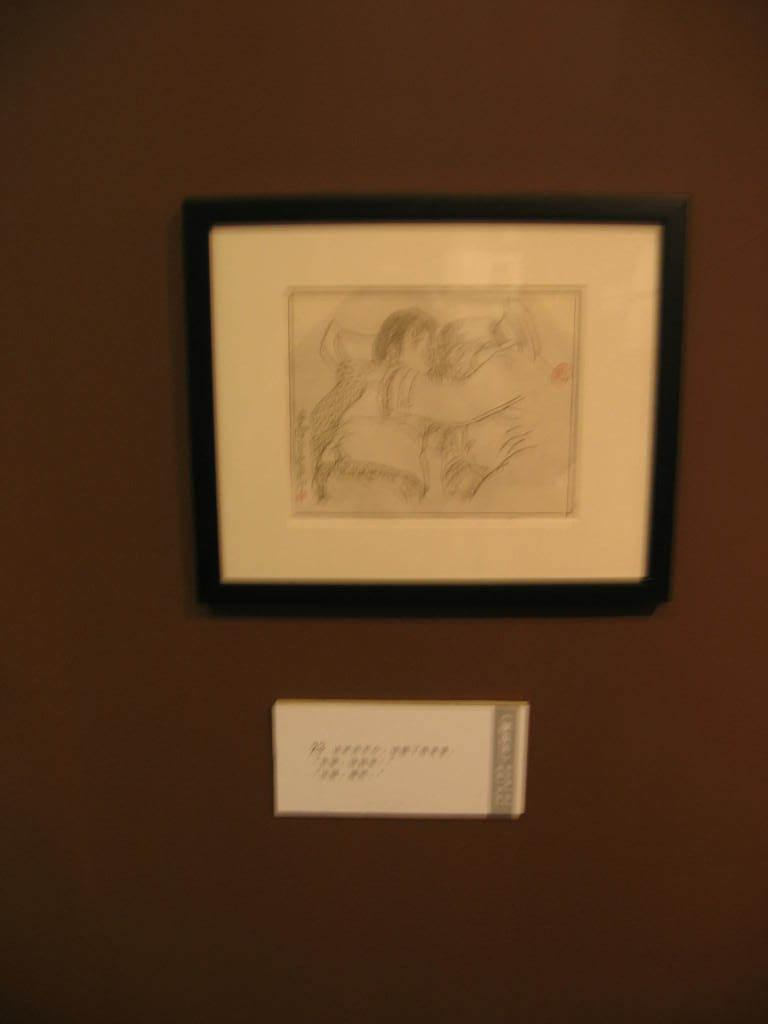What can be seen on the wall in the picture? There is a frame present on the wall. Can you describe the frame in the picture? Unfortunately, the details of the frame cannot be determined from the provided facts. How many robins can be seen carrying a basket in the picture? There are no robins or baskets present in the picture. What type of care is being provided to the frame in the picture? There is no indication of any care being provided to the frame in the picture. 